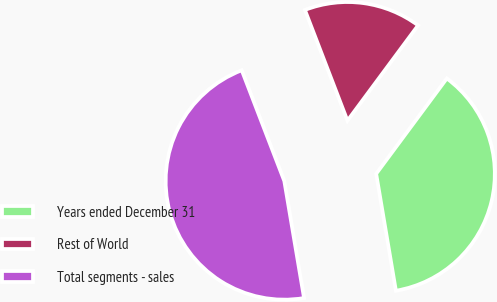Convert chart. <chart><loc_0><loc_0><loc_500><loc_500><pie_chart><fcel>Years ended December 31<fcel>Rest of World<fcel>Total segments - sales<nl><fcel>37.19%<fcel>15.99%<fcel>46.82%<nl></chart> 